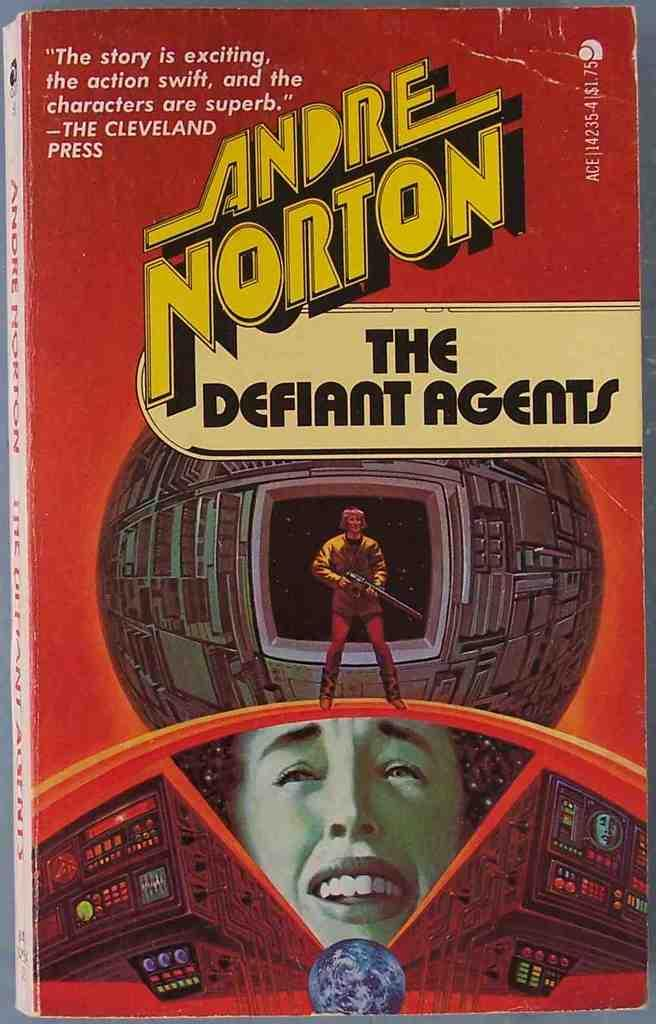<image>
Summarize the visual content of the image. A book by Andre Norton called The Defiant Agents. 